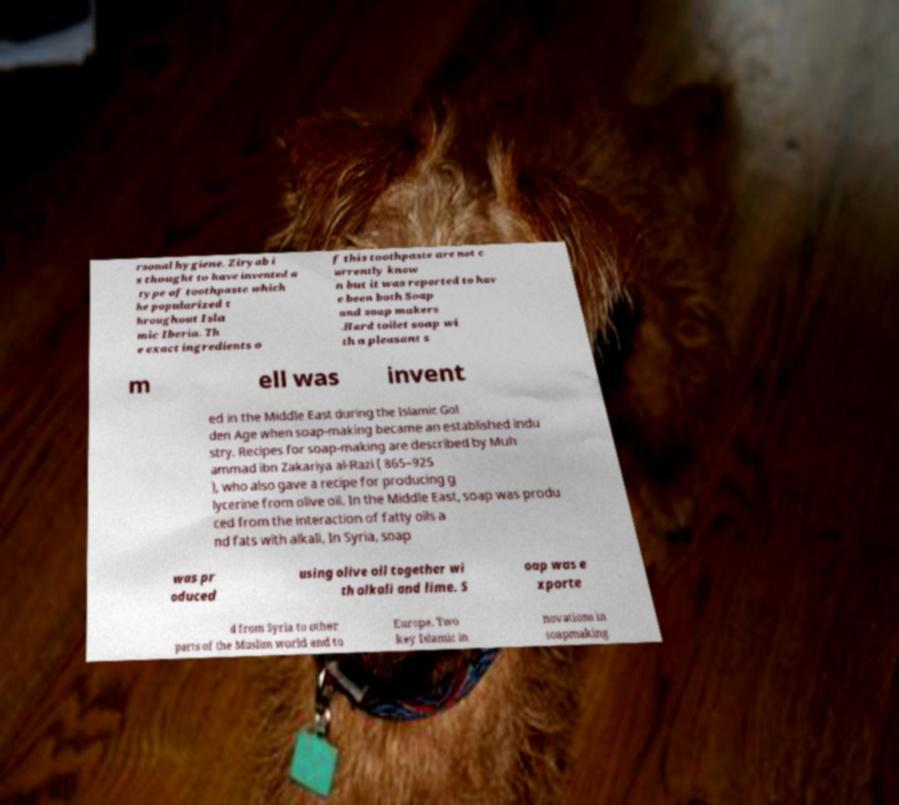There's text embedded in this image that I need extracted. Can you transcribe it verbatim? rsonal hygiene. Ziryab i s thought to have invented a type of toothpaste which he popularized t hroughout Isla mic Iberia. Th e exact ingredients o f this toothpaste are not c urrently know n but it was reported to hav e been both Soap and soap makers .Hard toilet soap wi th a pleasant s m ell was invent ed in the Middle East during the Islamic Gol den Age when soap-making became an established indu stry. Recipes for soap-making are described by Muh ammad ibn Zakariya al-Razi ( 865–925 ), who also gave a recipe for producing g lycerine from olive oil. In the Middle East, soap was produ ced from the interaction of fatty oils a nd fats with alkali. In Syria, soap was pr oduced using olive oil together wi th alkali and lime. S oap was e xporte d from Syria to other parts of the Muslim world and to Europe. Two key Islamic in novations in soapmaking 